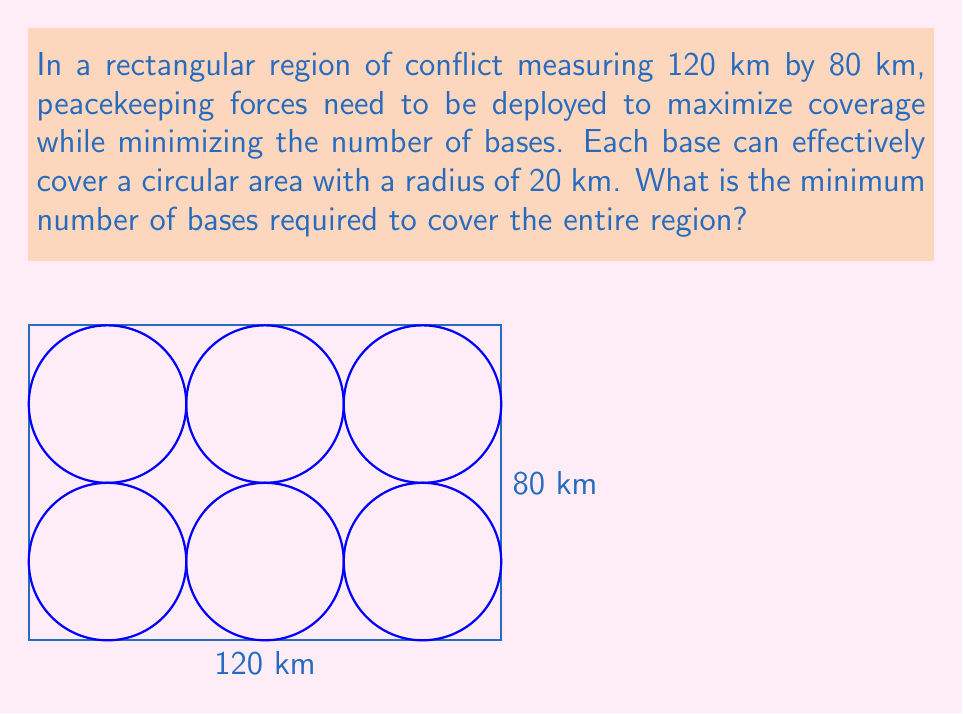Can you solve this math problem? To solve this problem, we need to follow these steps:

1) First, we need to understand the coverage area of each base:
   Area of coverage = $\pi r^2 = \pi (20)^2 = 400\pi$ km²

2) Now, let's calculate the total area to be covered:
   Total area = $120 \text{ km} \times 80 \text{ km} = 9600$ km²

3) We might think we could simply divide the total area by the coverage area of each base:
   $9600 \div (400\pi) \approx 7.64$

   However, this would be incorrect because circular coverage areas overlap and leave gaps.

4) The most efficient packing of circles in a plane is a hexagonal packing, where each circle is surrounded by 6 others. This packing has an efficiency of about 90.69%.

5) Taking this efficiency into account:
   Number of bases = $9600 \div (400\pi \times 0.9069) \approx 8.42$

6) Since we can't have a fractional number of bases, we round up to the nearest whole number.

7) To verify, we can arrange 9 bases in a 3x3 grid:
   - Horizontal spacing: 120 km ÷ 3 = 40 km
   - Vertical spacing: 80 km ÷ 3 ≈ 26.67 km

   This arrangement ensures complete coverage with some overlap.
Answer: 9 bases 